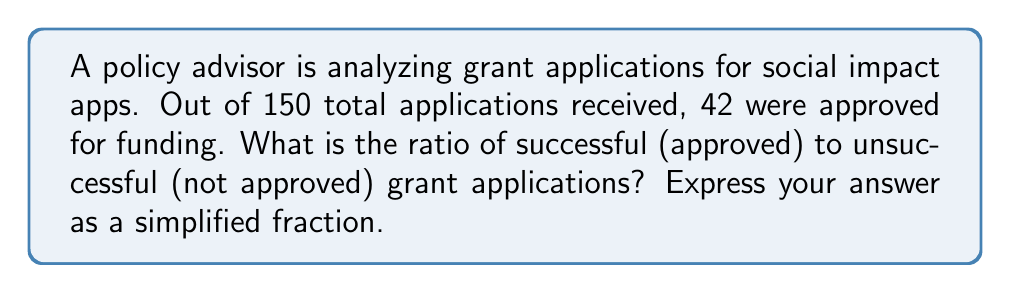Show me your answer to this math problem. To solve this problem, we need to follow these steps:

1. Identify the number of successful applications:
   Successful applications = 42

2. Calculate the number of unsuccessful applications:
   Total applications = 150
   Unsuccessful applications = Total - Successful
   $150 - 42 = 108$

3. Set up the ratio of successful to unsuccessful applications:
   $\frac{\text{Successful}}{\text{Unsuccessful}} = \frac{42}{108}$

4. Simplify the fraction by finding the greatest common divisor (GCD):
   The GCD of 42 and 108 is 6.

5. Divide both the numerator and denominator by the GCD:
   $\frac{42 \div 6}{108 \div 6} = \frac{7}{18}$

Therefore, the simplified ratio of successful to unsuccessful grant applications is 7:18.
Answer: $\frac{7}{18}$ 